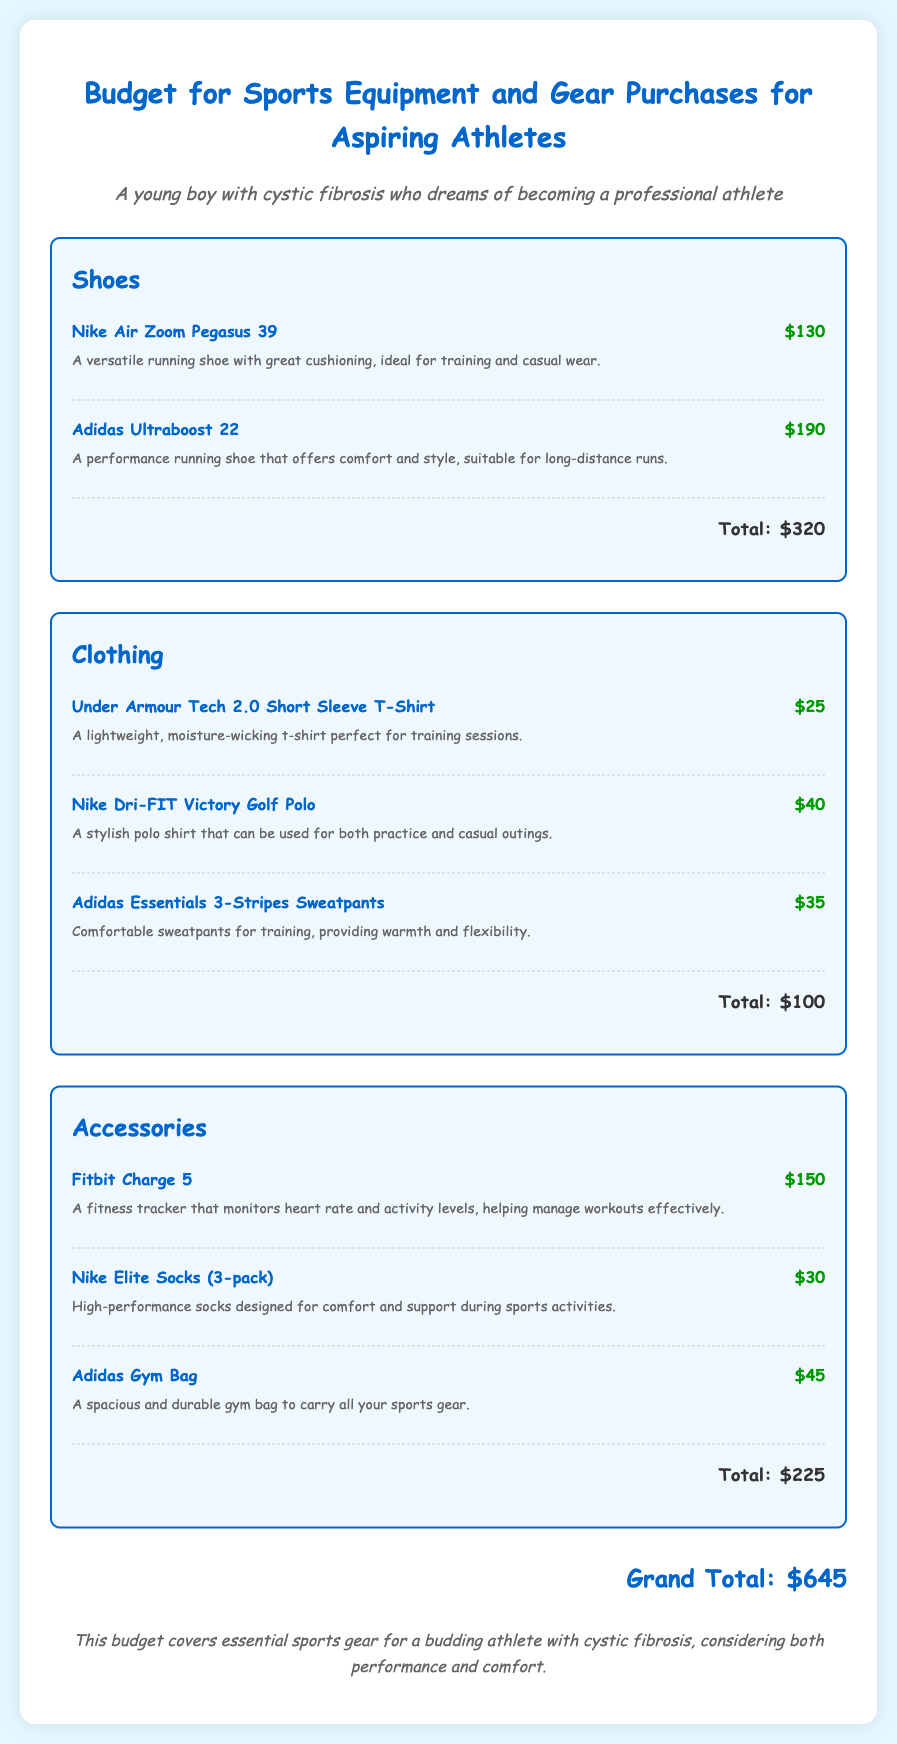What is the total cost for shoes? The total cost for shoes is given in the category section, which adds up to $320.
Answer: $320 What is the price of the Adidas Ultraboost 22? The price of the Adidas Ultraboost 22 is specifically mentioned next to the item, which is $190.
Answer: $190 What type of clothing is the Under Armour Tech 2.0 Short Sleeve T-Shirt? The Under Armour Tech 2.0 Short Sleeve T-Shirt is described as a lightweight, moisture-wicking t-shirt suitable for training.
Answer: Lightweight, moisture-wicking t-shirt How much do the Nike Elite Socks (3-pack) cost? The cost for the Nike Elite Socks (3-pack) is provided in the accessories section, which is $30.
Answer: $30 What is the grand total for all items? The grand total is provided at the bottom of the document, summarizing the costs of all categories, which is $645.
Answer: $645 Why is the budget particularly relevant for a young athlete with cystic fibrosis? The budget specifically addresses the needs of a budding athlete with cystic fibrosis, balancing performance and comfort.
Answer: Performance and comfort What kind of bag is listed in the accessories section? The accessories section mentions an Adidas Gym Bag, which is spacious and durable for carrying sports gear.
Answer: Adidas Gym Bag How many items are listed under clothing? There are three clothing items listed in the clothing category: Under Armour t-shirt, Nike polo, and Adidas sweatpants.
Answer: Three items Which shoe is recommended for long-distance runs? The Adidas Ultraboost 22 is specifically noted as a performance running shoe suitable for long-distance runs.
Answer: Adidas Ultraboost 22 